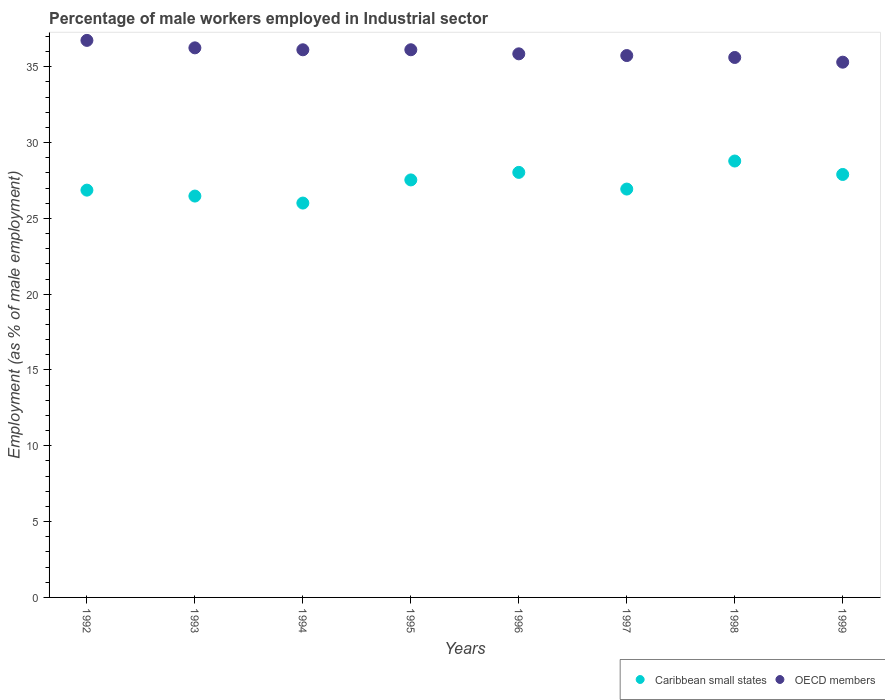How many different coloured dotlines are there?
Offer a very short reply. 2. What is the percentage of male workers employed in Industrial sector in OECD members in 1999?
Keep it short and to the point. 35.3. Across all years, what is the maximum percentage of male workers employed in Industrial sector in Caribbean small states?
Offer a terse response. 28.78. Across all years, what is the minimum percentage of male workers employed in Industrial sector in OECD members?
Your response must be concise. 35.3. In which year was the percentage of male workers employed in Industrial sector in OECD members maximum?
Offer a terse response. 1992. In which year was the percentage of male workers employed in Industrial sector in Caribbean small states minimum?
Make the answer very short. 1994. What is the total percentage of male workers employed in Industrial sector in Caribbean small states in the graph?
Give a very brief answer. 218.51. What is the difference between the percentage of male workers employed in Industrial sector in OECD members in 1992 and that in 1995?
Your response must be concise. 0.62. What is the difference between the percentage of male workers employed in Industrial sector in Caribbean small states in 1994 and the percentage of male workers employed in Industrial sector in OECD members in 1995?
Ensure brevity in your answer.  -10.11. What is the average percentage of male workers employed in Industrial sector in Caribbean small states per year?
Your answer should be very brief. 27.31. In the year 1998, what is the difference between the percentage of male workers employed in Industrial sector in Caribbean small states and percentage of male workers employed in Industrial sector in OECD members?
Provide a succinct answer. -6.83. In how many years, is the percentage of male workers employed in Industrial sector in OECD members greater than 20 %?
Make the answer very short. 8. What is the ratio of the percentage of male workers employed in Industrial sector in Caribbean small states in 1993 to that in 1994?
Ensure brevity in your answer.  1.02. Is the percentage of male workers employed in Industrial sector in OECD members in 1992 less than that in 1993?
Your answer should be very brief. No. What is the difference between the highest and the second highest percentage of male workers employed in Industrial sector in OECD members?
Provide a short and direct response. 0.49. What is the difference between the highest and the lowest percentage of male workers employed in Industrial sector in Caribbean small states?
Provide a short and direct response. 2.77. Is the sum of the percentage of male workers employed in Industrial sector in OECD members in 1995 and 1997 greater than the maximum percentage of male workers employed in Industrial sector in Caribbean small states across all years?
Your answer should be very brief. Yes. Does the percentage of male workers employed in Industrial sector in OECD members monotonically increase over the years?
Keep it short and to the point. No. How many years are there in the graph?
Offer a terse response. 8. Does the graph contain grids?
Provide a short and direct response. No. How many legend labels are there?
Your response must be concise. 2. What is the title of the graph?
Give a very brief answer. Percentage of male workers employed in Industrial sector. Does "Mexico" appear as one of the legend labels in the graph?
Your answer should be very brief. No. What is the label or title of the X-axis?
Ensure brevity in your answer.  Years. What is the label or title of the Y-axis?
Your answer should be compact. Employment (as % of male employment). What is the Employment (as % of male employment) of Caribbean small states in 1992?
Your response must be concise. 26.86. What is the Employment (as % of male employment) in OECD members in 1992?
Provide a succinct answer. 36.74. What is the Employment (as % of male employment) in Caribbean small states in 1993?
Make the answer very short. 26.47. What is the Employment (as % of male employment) of OECD members in 1993?
Your answer should be compact. 36.24. What is the Employment (as % of male employment) of Caribbean small states in 1994?
Ensure brevity in your answer.  26.01. What is the Employment (as % of male employment) in OECD members in 1994?
Offer a very short reply. 36.12. What is the Employment (as % of male employment) of Caribbean small states in 1995?
Your answer should be very brief. 27.53. What is the Employment (as % of male employment) of OECD members in 1995?
Offer a very short reply. 36.12. What is the Employment (as % of male employment) of Caribbean small states in 1996?
Ensure brevity in your answer.  28.03. What is the Employment (as % of male employment) in OECD members in 1996?
Give a very brief answer. 35.85. What is the Employment (as % of male employment) in Caribbean small states in 1997?
Offer a very short reply. 26.93. What is the Employment (as % of male employment) in OECD members in 1997?
Provide a succinct answer. 35.74. What is the Employment (as % of male employment) of Caribbean small states in 1998?
Provide a short and direct response. 28.78. What is the Employment (as % of male employment) in OECD members in 1998?
Provide a succinct answer. 35.61. What is the Employment (as % of male employment) in Caribbean small states in 1999?
Offer a very short reply. 27.89. What is the Employment (as % of male employment) in OECD members in 1999?
Your answer should be compact. 35.3. Across all years, what is the maximum Employment (as % of male employment) in Caribbean small states?
Provide a short and direct response. 28.78. Across all years, what is the maximum Employment (as % of male employment) in OECD members?
Provide a succinct answer. 36.74. Across all years, what is the minimum Employment (as % of male employment) in Caribbean small states?
Offer a very short reply. 26.01. Across all years, what is the minimum Employment (as % of male employment) in OECD members?
Provide a succinct answer. 35.3. What is the total Employment (as % of male employment) in Caribbean small states in the graph?
Keep it short and to the point. 218.51. What is the total Employment (as % of male employment) in OECD members in the graph?
Offer a very short reply. 287.71. What is the difference between the Employment (as % of male employment) in Caribbean small states in 1992 and that in 1993?
Keep it short and to the point. 0.39. What is the difference between the Employment (as % of male employment) of OECD members in 1992 and that in 1993?
Give a very brief answer. 0.49. What is the difference between the Employment (as % of male employment) of Caribbean small states in 1992 and that in 1994?
Ensure brevity in your answer.  0.85. What is the difference between the Employment (as % of male employment) in OECD members in 1992 and that in 1994?
Offer a very short reply. 0.62. What is the difference between the Employment (as % of male employment) in Caribbean small states in 1992 and that in 1995?
Your answer should be very brief. -0.67. What is the difference between the Employment (as % of male employment) of OECD members in 1992 and that in 1995?
Offer a terse response. 0.62. What is the difference between the Employment (as % of male employment) in Caribbean small states in 1992 and that in 1996?
Your answer should be very brief. -1.17. What is the difference between the Employment (as % of male employment) in OECD members in 1992 and that in 1996?
Your answer should be compact. 0.89. What is the difference between the Employment (as % of male employment) in Caribbean small states in 1992 and that in 1997?
Give a very brief answer. -0.07. What is the difference between the Employment (as % of male employment) of OECD members in 1992 and that in 1997?
Offer a terse response. 1. What is the difference between the Employment (as % of male employment) of Caribbean small states in 1992 and that in 1998?
Make the answer very short. -1.92. What is the difference between the Employment (as % of male employment) of OECD members in 1992 and that in 1998?
Keep it short and to the point. 1.13. What is the difference between the Employment (as % of male employment) of Caribbean small states in 1992 and that in 1999?
Offer a terse response. -1.03. What is the difference between the Employment (as % of male employment) in OECD members in 1992 and that in 1999?
Offer a terse response. 1.44. What is the difference between the Employment (as % of male employment) in Caribbean small states in 1993 and that in 1994?
Keep it short and to the point. 0.46. What is the difference between the Employment (as % of male employment) of OECD members in 1993 and that in 1994?
Your answer should be compact. 0.13. What is the difference between the Employment (as % of male employment) of Caribbean small states in 1993 and that in 1995?
Ensure brevity in your answer.  -1.06. What is the difference between the Employment (as % of male employment) in OECD members in 1993 and that in 1995?
Provide a succinct answer. 0.13. What is the difference between the Employment (as % of male employment) of Caribbean small states in 1993 and that in 1996?
Your answer should be compact. -1.56. What is the difference between the Employment (as % of male employment) of OECD members in 1993 and that in 1996?
Make the answer very short. 0.39. What is the difference between the Employment (as % of male employment) in Caribbean small states in 1993 and that in 1997?
Your answer should be very brief. -0.46. What is the difference between the Employment (as % of male employment) of OECD members in 1993 and that in 1997?
Provide a short and direct response. 0.51. What is the difference between the Employment (as % of male employment) in Caribbean small states in 1993 and that in 1998?
Provide a short and direct response. -2.31. What is the difference between the Employment (as % of male employment) in OECD members in 1993 and that in 1998?
Offer a very short reply. 0.63. What is the difference between the Employment (as % of male employment) in Caribbean small states in 1993 and that in 1999?
Keep it short and to the point. -1.42. What is the difference between the Employment (as % of male employment) in OECD members in 1993 and that in 1999?
Provide a succinct answer. 0.95. What is the difference between the Employment (as % of male employment) of Caribbean small states in 1994 and that in 1995?
Ensure brevity in your answer.  -1.53. What is the difference between the Employment (as % of male employment) in OECD members in 1994 and that in 1995?
Your answer should be very brief. -0. What is the difference between the Employment (as % of male employment) in Caribbean small states in 1994 and that in 1996?
Provide a succinct answer. -2.02. What is the difference between the Employment (as % of male employment) in OECD members in 1994 and that in 1996?
Offer a terse response. 0.27. What is the difference between the Employment (as % of male employment) in Caribbean small states in 1994 and that in 1997?
Provide a succinct answer. -0.92. What is the difference between the Employment (as % of male employment) of OECD members in 1994 and that in 1997?
Ensure brevity in your answer.  0.38. What is the difference between the Employment (as % of male employment) in Caribbean small states in 1994 and that in 1998?
Your answer should be very brief. -2.77. What is the difference between the Employment (as % of male employment) in OECD members in 1994 and that in 1998?
Your response must be concise. 0.51. What is the difference between the Employment (as % of male employment) of Caribbean small states in 1994 and that in 1999?
Your response must be concise. -1.89. What is the difference between the Employment (as % of male employment) in OECD members in 1994 and that in 1999?
Make the answer very short. 0.82. What is the difference between the Employment (as % of male employment) of Caribbean small states in 1995 and that in 1996?
Make the answer very short. -0.5. What is the difference between the Employment (as % of male employment) in OECD members in 1995 and that in 1996?
Ensure brevity in your answer.  0.27. What is the difference between the Employment (as % of male employment) of Caribbean small states in 1995 and that in 1997?
Keep it short and to the point. 0.6. What is the difference between the Employment (as % of male employment) in OECD members in 1995 and that in 1997?
Provide a succinct answer. 0.38. What is the difference between the Employment (as % of male employment) of Caribbean small states in 1995 and that in 1998?
Keep it short and to the point. -1.25. What is the difference between the Employment (as % of male employment) of OECD members in 1995 and that in 1998?
Give a very brief answer. 0.51. What is the difference between the Employment (as % of male employment) of Caribbean small states in 1995 and that in 1999?
Keep it short and to the point. -0.36. What is the difference between the Employment (as % of male employment) of OECD members in 1995 and that in 1999?
Keep it short and to the point. 0.82. What is the difference between the Employment (as % of male employment) of Caribbean small states in 1996 and that in 1997?
Offer a very short reply. 1.1. What is the difference between the Employment (as % of male employment) in OECD members in 1996 and that in 1997?
Provide a succinct answer. 0.11. What is the difference between the Employment (as % of male employment) in Caribbean small states in 1996 and that in 1998?
Ensure brevity in your answer.  -0.75. What is the difference between the Employment (as % of male employment) of OECD members in 1996 and that in 1998?
Give a very brief answer. 0.24. What is the difference between the Employment (as % of male employment) of Caribbean small states in 1996 and that in 1999?
Make the answer very short. 0.14. What is the difference between the Employment (as % of male employment) of OECD members in 1996 and that in 1999?
Offer a very short reply. 0.55. What is the difference between the Employment (as % of male employment) in Caribbean small states in 1997 and that in 1998?
Provide a succinct answer. -1.85. What is the difference between the Employment (as % of male employment) of OECD members in 1997 and that in 1998?
Ensure brevity in your answer.  0.13. What is the difference between the Employment (as % of male employment) in Caribbean small states in 1997 and that in 1999?
Provide a short and direct response. -0.96. What is the difference between the Employment (as % of male employment) in OECD members in 1997 and that in 1999?
Give a very brief answer. 0.44. What is the difference between the Employment (as % of male employment) of Caribbean small states in 1998 and that in 1999?
Your answer should be very brief. 0.89. What is the difference between the Employment (as % of male employment) of OECD members in 1998 and that in 1999?
Your answer should be compact. 0.31. What is the difference between the Employment (as % of male employment) of Caribbean small states in 1992 and the Employment (as % of male employment) of OECD members in 1993?
Offer a terse response. -9.38. What is the difference between the Employment (as % of male employment) in Caribbean small states in 1992 and the Employment (as % of male employment) in OECD members in 1994?
Offer a very short reply. -9.26. What is the difference between the Employment (as % of male employment) in Caribbean small states in 1992 and the Employment (as % of male employment) in OECD members in 1995?
Your answer should be very brief. -9.26. What is the difference between the Employment (as % of male employment) in Caribbean small states in 1992 and the Employment (as % of male employment) in OECD members in 1996?
Your answer should be compact. -8.99. What is the difference between the Employment (as % of male employment) in Caribbean small states in 1992 and the Employment (as % of male employment) in OECD members in 1997?
Make the answer very short. -8.88. What is the difference between the Employment (as % of male employment) in Caribbean small states in 1992 and the Employment (as % of male employment) in OECD members in 1998?
Keep it short and to the point. -8.75. What is the difference between the Employment (as % of male employment) of Caribbean small states in 1992 and the Employment (as % of male employment) of OECD members in 1999?
Give a very brief answer. -8.44. What is the difference between the Employment (as % of male employment) of Caribbean small states in 1993 and the Employment (as % of male employment) of OECD members in 1994?
Provide a succinct answer. -9.65. What is the difference between the Employment (as % of male employment) in Caribbean small states in 1993 and the Employment (as % of male employment) in OECD members in 1995?
Provide a short and direct response. -9.65. What is the difference between the Employment (as % of male employment) in Caribbean small states in 1993 and the Employment (as % of male employment) in OECD members in 1996?
Ensure brevity in your answer.  -9.38. What is the difference between the Employment (as % of male employment) in Caribbean small states in 1993 and the Employment (as % of male employment) in OECD members in 1997?
Keep it short and to the point. -9.27. What is the difference between the Employment (as % of male employment) of Caribbean small states in 1993 and the Employment (as % of male employment) of OECD members in 1998?
Provide a succinct answer. -9.14. What is the difference between the Employment (as % of male employment) of Caribbean small states in 1993 and the Employment (as % of male employment) of OECD members in 1999?
Keep it short and to the point. -8.83. What is the difference between the Employment (as % of male employment) of Caribbean small states in 1994 and the Employment (as % of male employment) of OECD members in 1995?
Offer a very short reply. -10.11. What is the difference between the Employment (as % of male employment) in Caribbean small states in 1994 and the Employment (as % of male employment) in OECD members in 1996?
Offer a very short reply. -9.84. What is the difference between the Employment (as % of male employment) of Caribbean small states in 1994 and the Employment (as % of male employment) of OECD members in 1997?
Give a very brief answer. -9.73. What is the difference between the Employment (as % of male employment) of Caribbean small states in 1994 and the Employment (as % of male employment) of OECD members in 1998?
Provide a succinct answer. -9.6. What is the difference between the Employment (as % of male employment) in Caribbean small states in 1994 and the Employment (as % of male employment) in OECD members in 1999?
Offer a terse response. -9.29. What is the difference between the Employment (as % of male employment) in Caribbean small states in 1995 and the Employment (as % of male employment) in OECD members in 1996?
Ensure brevity in your answer.  -8.32. What is the difference between the Employment (as % of male employment) in Caribbean small states in 1995 and the Employment (as % of male employment) in OECD members in 1997?
Make the answer very short. -8.2. What is the difference between the Employment (as % of male employment) in Caribbean small states in 1995 and the Employment (as % of male employment) in OECD members in 1998?
Your answer should be compact. -8.08. What is the difference between the Employment (as % of male employment) in Caribbean small states in 1995 and the Employment (as % of male employment) in OECD members in 1999?
Offer a very short reply. -7.76. What is the difference between the Employment (as % of male employment) in Caribbean small states in 1996 and the Employment (as % of male employment) in OECD members in 1997?
Offer a very short reply. -7.71. What is the difference between the Employment (as % of male employment) in Caribbean small states in 1996 and the Employment (as % of male employment) in OECD members in 1998?
Offer a terse response. -7.58. What is the difference between the Employment (as % of male employment) in Caribbean small states in 1996 and the Employment (as % of male employment) in OECD members in 1999?
Provide a succinct answer. -7.27. What is the difference between the Employment (as % of male employment) in Caribbean small states in 1997 and the Employment (as % of male employment) in OECD members in 1998?
Keep it short and to the point. -8.68. What is the difference between the Employment (as % of male employment) of Caribbean small states in 1997 and the Employment (as % of male employment) of OECD members in 1999?
Your answer should be very brief. -8.37. What is the difference between the Employment (as % of male employment) in Caribbean small states in 1998 and the Employment (as % of male employment) in OECD members in 1999?
Offer a very short reply. -6.52. What is the average Employment (as % of male employment) in Caribbean small states per year?
Offer a very short reply. 27.31. What is the average Employment (as % of male employment) in OECD members per year?
Ensure brevity in your answer.  35.96. In the year 1992, what is the difference between the Employment (as % of male employment) in Caribbean small states and Employment (as % of male employment) in OECD members?
Offer a terse response. -9.88. In the year 1993, what is the difference between the Employment (as % of male employment) in Caribbean small states and Employment (as % of male employment) in OECD members?
Give a very brief answer. -9.77. In the year 1994, what is the difference between the Employment (as % of male employment) in Caribbean small states and Employment (as % of male employment) in OECD members?
Give a very brief answer. -10.11. In the year 1995, what is the difference between the Employment (as % of male employment) of Caribbean small states and Employment (as % of male employment) of OECD members?
Your answer should be compact. -8.58. In the year 1996, what is the difference between the Employment (as % of male employment) in Caribbean small states and Employment (as % of male employment) in OECD members?
Your answer should be very brief. -7.82. In the year 1997, what is the difference between the Employment (as % of male employment) of Caribbean small states and Employment (as % of male employment) of OECD members?
Your answer should be very brief. -8.8. In the year 1998, what is the difference between the Employment (as % of male employment) in Caribbean small states and Employment (as % of male employment) in OECD members?
Ensure brevity in your answer.  -6.83. In the year 1999, what is the difference between the Employment (as % of male employment) of Caribbean small states and Employment (as % of male employment) of OECD members?
Ensure brevity in your answer.  -7.4. What is the ratio of the Employment (as % of male employment) in Caribbean small states in 1992 to that in 1993?
Your answer should be compact. 1.01. What is the ratio of the Employment (as % of male employment) in OECD members in 1992 to that in 1993?
Keep it short and to the point. 1.01. What is the ratio of the Employment (as % of male employment) of Caribbean small states in 1992 to that in 1994?
Ensure brevity in your answer.  1.03. What is the ratio of the Employment (as % of male employment) in OECD members in 1992 to that in 1994?
Ensure brevity in your answer.  1.02. What is the ratio of the Employment (as % of male employment) of Caribbean small states in 1992 to that in 1995?
Your response must be concise. 0.98. What is the ratio of the Employment (as % of male employment) of OECD members in 1992 to that in 1995?
Offer a very short reply. 1.02. What is the ratio of the Employment (as % of male employment) of Caribbean small states in 1992 to that in 1996?
Provide a succinct answer. 0.96. What is the ratio of the Employment (as % of male employment) in OECD members in 1992 to that in 1996?
Your answer should be very brief. 1.02. What is the ratio of the Employment (as % of male employment) of Caribbean small states in 1992 to that in 1997?
Make the answer very short. 1. What is the ratio of the Employment (as % of male employment) of OECD members in 1992 to that in 1997?
Your answer should be very brief. 1.03. What is the ratio of the Employment (as % of male employment) in OECD members in 1992 to that in 1998?
Offer a terse response. 1.03. What is the ratio of the Employment (as % of male employment) of Caribbean small states in 1992 to that in 1999?
Provide a succinct answer. 0.96. What is the ratio of the Employment (as % of male employment) in OECD members in 1992 to that in 1999?
Offer a very short reply. 1.04. What is the ratio of the Employment (as % of male employment) in Caribbean small states in 1993 to that in 1994?
Ensure brevity in your answer.  1.02. What is the ratio of the Employment (as % of male employment) of OECD members in 1993 to that in 1994?
Provide a short and direct response. 1. What is the ratio of the Employment (as % of male employment) of Caribbean small states in 1993 to that in 1995?
Give a very brief answer. 0.96. What is the ratio of the Employment (as % of male employment) in OECD members in 1993 to that in 1995?
Your response must be concise. 1. What is the ratio of the Employment (as % of male employment) of Caribbean small states in 1993 to that in 1996?
Ensure brevity in your answer.  0.94. What is the ratio of the Employment (as % of male employment) in OECD members in 1993 to that in 1996?
Ensure brevity in your answer.  1.01. What is the ratio of the Employment (as % of male employment) in Caribbean small states in 1993 to that in 1997?
Your answer should be compact. 0.98. What is the ratio of the Employment (as % of male employment) of OECD members in 1993 to that in 1997?
Offer a terse response. 1.01. What is the ratio of the Employment (as % of male employment) of Caribbean small states in 1993 to that in 1998?
Provide a succinct answer. 0.92. What is the ratio of the Employment (as % of male employment) in OECD members in 1993 to that in 1998?
Ensure brevity in your answer.  1.02. What is the ratio of the Employment (as % of male employment) in Caribbean small states in 1993 to that in 1999?
Offer a very short reply. 0.95. What is the ratio of the Employment (as % of male employment) of OECD members in 1993 to that in 1999?
Make the answer very short. 1.03. What is the ratio of the Employment (as % of male employment) in Caribbean small states in 1994 to that in 1995?
Your response must be concise. 0.94. What is the ratio of the Employment (as % of male employment) in Caribbean small states in 1994 to that in 1996?
Keep it short and to the point. 0.93. What is the ratio of the Employment (as % of male employment) of OECD members in 1994 to that in 1996?
Give a very brief answer. 1.01. What is the ratio of the Employment (as % of male employment) in Caribbean small states in 1994 to that in 1997?
Your answer should be very brief. 0.97. What is the ratio of the Employment (as % of male employment) in OECD members in 1994 to that in 1997?
Ensure brevity in your answer.  1.01. What is the ratio of the Employment (as % of male employment) of Caribbean small states in 1994 to that in 1998?
Provide a short and direct response. 0.9. What is the ratio of the Employment (as % of male employment) of OECD members in 1994 to that in 1998?
Your response must be concise. 1.01. What is the ratio of the Employment (as % of male employment) in Caribbean small states in 1994 to that in 1999?
Your answer should be very brief. 0.93. What is the ratio of the Employment (as % of male employment) in OECD members in 1994 to that in 1999?
Your answer should be compact. 1.02. What is the ratio of the Employment (as % of male employment) in Caribbean small states in 1995 to that in 1996?
Keep it short and to the point. 0.98. What is the ratio of the Employment (as % of male employment) of OECD members in 1995 to that in 1996?
Keep it short and to the point. 1.01. What is the ratio of the Employment (as % of male employment) of Caribbean small states in 1995 to that in 1997?
Keep it short and to the point. 1.02. What is the ratio of the Employment (as % of male employment) of OECD members in 1995 to that in 1997?
Your response must be concise. 1.01. What is the ratio of the Employment (as % of male employment) in Caribbean small states in 1995 to that in 1998?
Your answer should be compact. 0.96. What is the ratio of the Employment (as % of male employment) of OECD members in 1995 to that in 1998?
Your response must be concise. 1.01. What is the ratio of the Employment (as % of male employment) of Caribbean small states in 1995 to that in 1999?
Give a very brief answer. 0.99. What is the ratio of the Employment (as % of male employment) of OECD members in 1995 to that in 1999?
Make the answer very short. 1.02. What is the ratio of the Employment (as % of male employment) in Caribbean small states in 1996 to that in 1997?
Offer a terse response. 1.04. What is the ratio of the Employment (as % of male employment) in Caribbean small states in 1996 to that in 1998?
Make the answer very short. 0.97. What is the ratio of the Employment (as % of male employment) in Caribbean small states in 1996 to that in 1999?
Your response must be concise. 1. What is the ratio of the Employment (as % of male employment) of OECD members in 1996 to that in 1999?
Your answer should be very brief. 1.02. What is the ratio of the Employment (as % of male employment) of Caribbean small states in 1997 to that in 1998?
Offer a terse response. 0.94. What is the ratio of the Employment (as % of male employment) in OECD members in 1997 to that in 1998?
Ensure brevity in your answer.  1. What is the ratio of the Employment (as % of male employment) of Caribbean small states in 1997 to that in 1999?
Provide a succinct answer. 0.97. What is the ratio of the Employment (as % of male employment) in OECD members in 1997 to that in 1999?
Provide a short and direct response. 1.01. What is the ratio of the Employment (as % of male employment) of Caribbean small states in 1998 to that in 1999?
Your response must be concise. 1.03. What is the ratio of the Employment (as % of male employment) in OECD members in 1998 to that in 1999?
Offer a terse response. 1.01. What is the difference between the highest and the second highest Employment (as % of male employment) of Caribbean small states?
Provide a short and direct response. 0.75. What is the difference between the highest and the second highest Employment (as % of male employment) in OECD members?
Your response must be concise. 0.49. What is the difference between the highest and the lowest Employment (as % of male employment) of Caribbean small states?
Your answer should be very brief. 2.77. What is the difference between the highest and the lowest Employment (as % of male employment) of OECD members?
Ensure brevity in your answer.  1.44. 